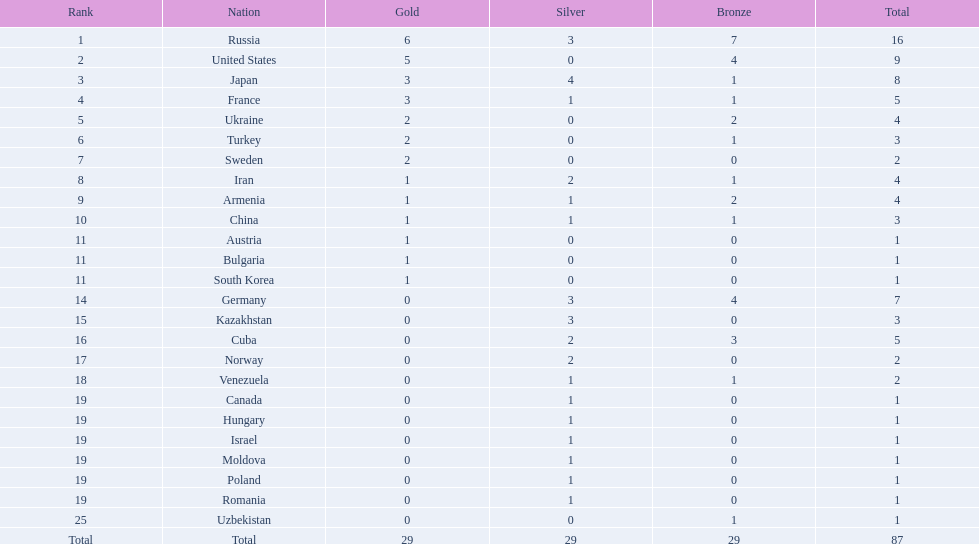In which position did iran rank? 8. In which position did germany rank? 14. Which country between them made it to the top 10 ranks? Germany. 